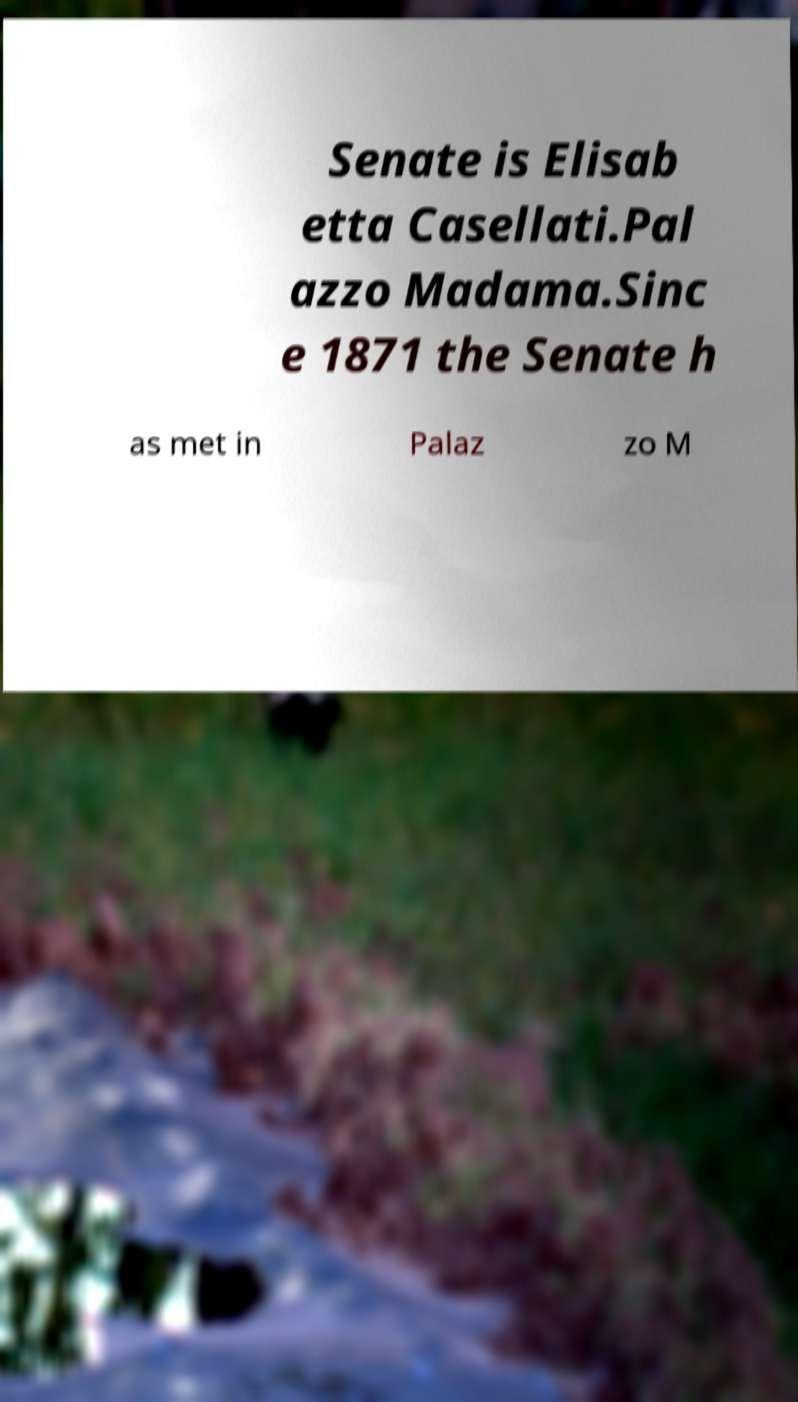What messages or text are displayed in this image? I need them in a readable, typed format. Senate is Elisab etta Casellati.Pal azzo Madama.Sinc e 1871 the Senate h as met in Palaz zo M 